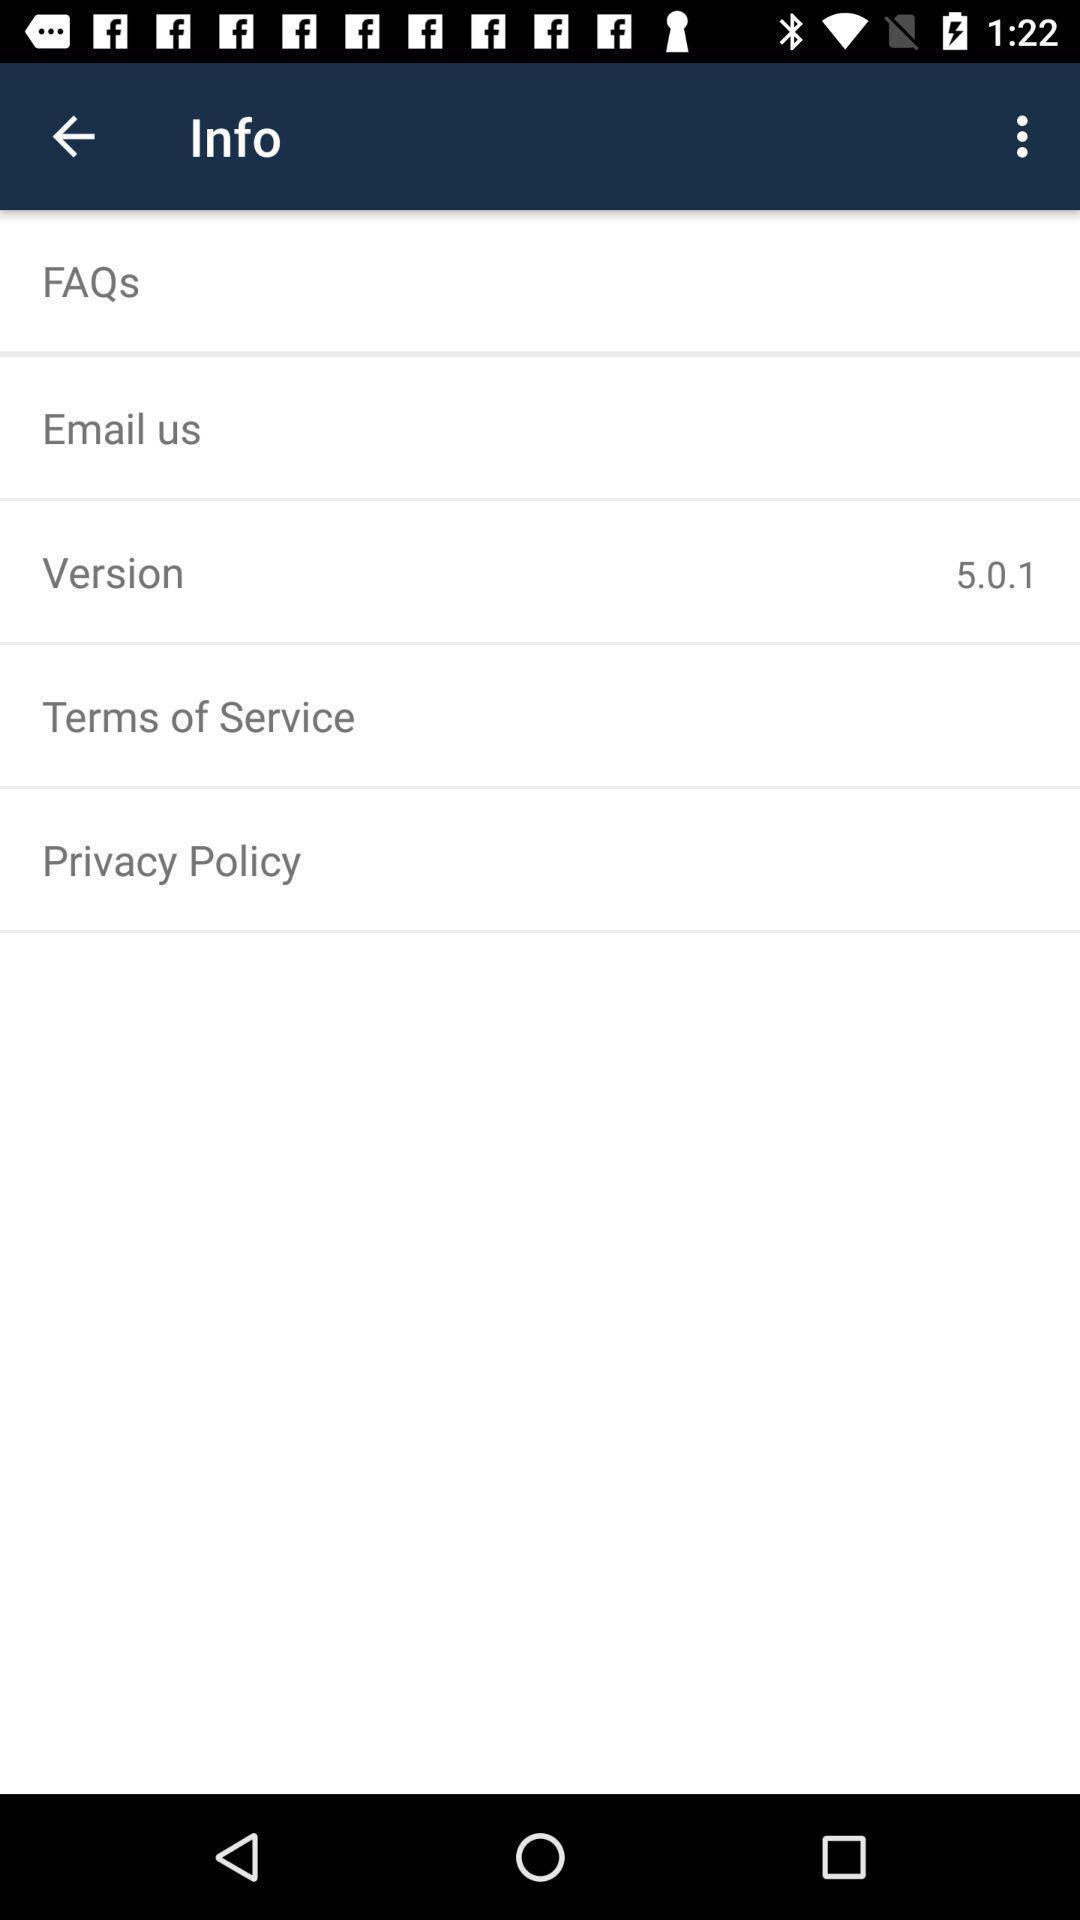Describe the content in this image. Screen displaying the info page of a payroll app. 